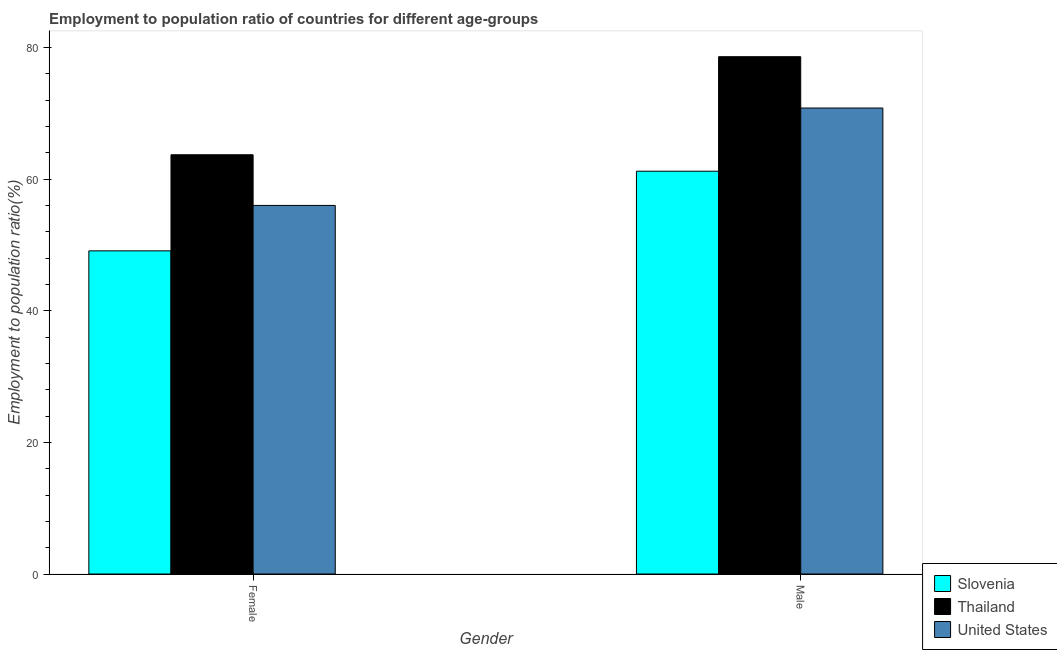How many different coloured bars are there?
Your answer should be compact. 3. Are the number of bars per tick equal to the number of legend labels?
Give a very brief answer. Yes. Are the number of bars on each tick of the X-axis equal?
Keep it short and to the point. Yes. What is the employment to population ratio(male) in Thailand?
Your response must be concise. 78.6. Across all countries, what is the maximum employment to population ratio(female)?
Offer a terse response. 63.7. Across all countries, what is the minimum employment to population ratio(male)?
Ensure brevity in your answer.  61.2. In which country was the employment to population ratio(male) maximum?
Provide a short and direct response. Thailand. In which country was the employment to population ratio(female) minimum?
Provide a succinct answer. Slovenia. What is the total employment to population ratio(male) in the graph?
Keep it short and to the point. 210.6. What is the difference between the employment to population ratio(female) in Slovenia and that in Thailand?
Keep it short and to the point. -14.6. What is the difference between the employment to population ratio(male) in United States and the employment to population ratio(female) in Slovenia?
Provide a short and direct response. 21.7. What is the average employment to population ratio(male) per country?
Give a very brief answer. 70.2. What is the difference between the employment to population ratio(female) and employment to population ratio(male) in Thailand?
Provide a short and direct response. -14.9. What is the ratio of the employment to population ratio(female) in Slovenia to that in Thailand?
Your answer should be very brief. 0.77. Is the employment to population ratio(female) in United States less than that in Thailand?
Provide a succinct answer. Yes. What does the 1st bar from the left in Male represents?
Give a very brief answer. Slovenia. What does the 1st bar from the right in Male represents?
Provide a short and direct response. United States. How many bars are there?
Keep it short and to the point. 6. Are all the bars in the graph horizontal?
Provide a succinct answer. No. How many countries are there in the graph?
Your answer should be very brief. 3. Are the values on the major ticks of Y-axis written in scientific E-notation?
Your response must be concise. No. Does the graph contain any zero values?
Provide a short and direct response. No. Does the graph contain grids?
Provide a succinct answer. No. What is the title of the graph?
Provide a short and direct response. Employment to population ratio of countries for different age-groups. Does "Georgia" appear as one of the legend labels in the graph?
Your answer should be compact. No. What is the Employment to population ratio(%) of Slovenia in Female?
Ensure brevity in your answer.  49.1. What is the Employment to population ratio(%) of Thailand in Female?
Provide a succinct answer. 63.7. What is the Employment to population ratio(%) in Slovenia in Male?
Provide a short and direct response. 61.2. What is the Employment to population ratio(%) in Thailand in Male?
Ensure brevity in your answer.  78.6. What is the Employment to population ratio(%) in United States in Male?
Your response must be concise. 70.8. Across all Gender, what is the maximum Employment to population ratio(%) in Slovenia?
Provide a short and direct response. 61.2. Across all Gender, what is the maximum Employment to population ratio(%) in Thailand?
Your answer should be very brief. 78.6. Across all Gender, what is the maximum Employment to population ratio(%) in United States?
Keep it short and to the point. 70.8. Across all Gender, what is the minimum Employment to population ratio(%) of Slovenia?
Your answer should be compact. 49.1. Across all Gender, what is the minimum Employment to population ratio(%) in Thailand?
Ensure brevity in your answer.  63.7. Across all Gender, what is the minimum Employment to population ratio(%) of United States?
Give a very brief answer. 56. What is the total Employment to population ratio(%) of Slovenia in the graph?
Your answer should be compact. 110.3. What is the total Employment to population ratio(%) in Thailand in the graph?
Ensure brevity in your answer.  142.3. What is the total Employment to population ratio(%) in United States in the graph?
Make the answer very short. 126.8. What is the difference between the Employment to population ratio(%) of Slovenia in Female and that in Male?
Keep it short and to the point. -12.1. What is the difference between the Employment to population ratio(%) in Thailand in Female and that in Male?
Give a very brief answer. -14.9. What is the difference between the Employment to population ratio(%) of United States in Female and that in Male?
Offer a very short reply. -14.8. What is the difference between the Employment to population ratio(%) in Slovenia in Female and the Employment to population ratio(%) in Thailand in Male?
Your response must be concise. -29.5. What is the difference between the Employment to population ratio(%) in Slovenia in Female and the Employment to population ratio(%) in United States in Male?
Offer a very short reply. -21.7. What is the average Employment to population ratio(%) of Slovenia per Gender?
Your answer should be very brief. 55.15. What is the average Employment to population ratio(%) in Thailand per Gender?
Offer a very short reply. 71.15. What is the average Employment to population ratio(%) in United States per Gender?
Your answer should be compact. 63.4. What is the difference between the Employment to population ratio(%) of Slovenia and Employment to population ratio(%) of Thailand in Female?
Offer a terse response. -14.6. What is the difference between the Employment to population ratio(%) of Slovenia and Employment to population ratio(%) of Thailand in Male?
Keep it short and to the point. -17.4. What is the difference between the Employment to population ratio(%) in Thailand and Employment to population ratio(%) in United States in Male?
Provide a short and direct response. 7.8. What is the ratio of the Employment to population ratio(%) of Slovenia in Female to that in Male?
Your answer should be very brief. 0.8. What is the ratio of the Employment to population ratio(%) in Thailand in Female to that in Male?
Offer a very short reply. 0.81. What is the ratio of the Employment to population ratio(%) of United States in Female to that in Male?
Provide a short and direct response. 0.79. What is the difference between the highest and the second highest Employment to population ratio(%) in Slovenia?
Your response must be concise. 12.1. What is the difference between the highest and the second highest Employment to population ratio(%) of United States?
Your answer should be very brief. 14.8. What is the difference between the highest and the lowest Employment to population ratio(%) of Thailand?
Keep it short and to the point. 14.9. 